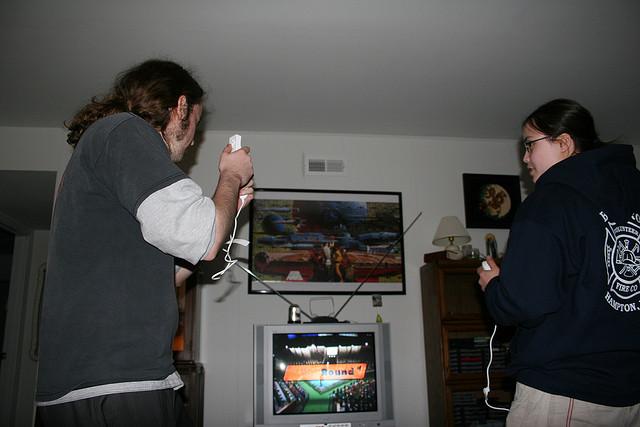Are they playing Xbox?
Short answer required. No. What color shirt is the guy on the right wearing?
Keep it brief. Black. What color is the man's shirt?
Give a very brief answer. Gray. Is the woman playing the game?
Answer briefly. Yes. What is the man holding?
Quick response, please. Wii remote. How many people have glasses?
Answer briefly. 1. What is the name of the hairstyle worn by the girl who has her back to the camera?
Quick response, please. Ponytail. Are these people friends?
Answer briefly. Yes. What is on the television?
Write a very short answer. Game. What is on the paintings on the wall?
Be succinct. People. Is the man wearing anything on his wrist?
Keep it brief. No. 